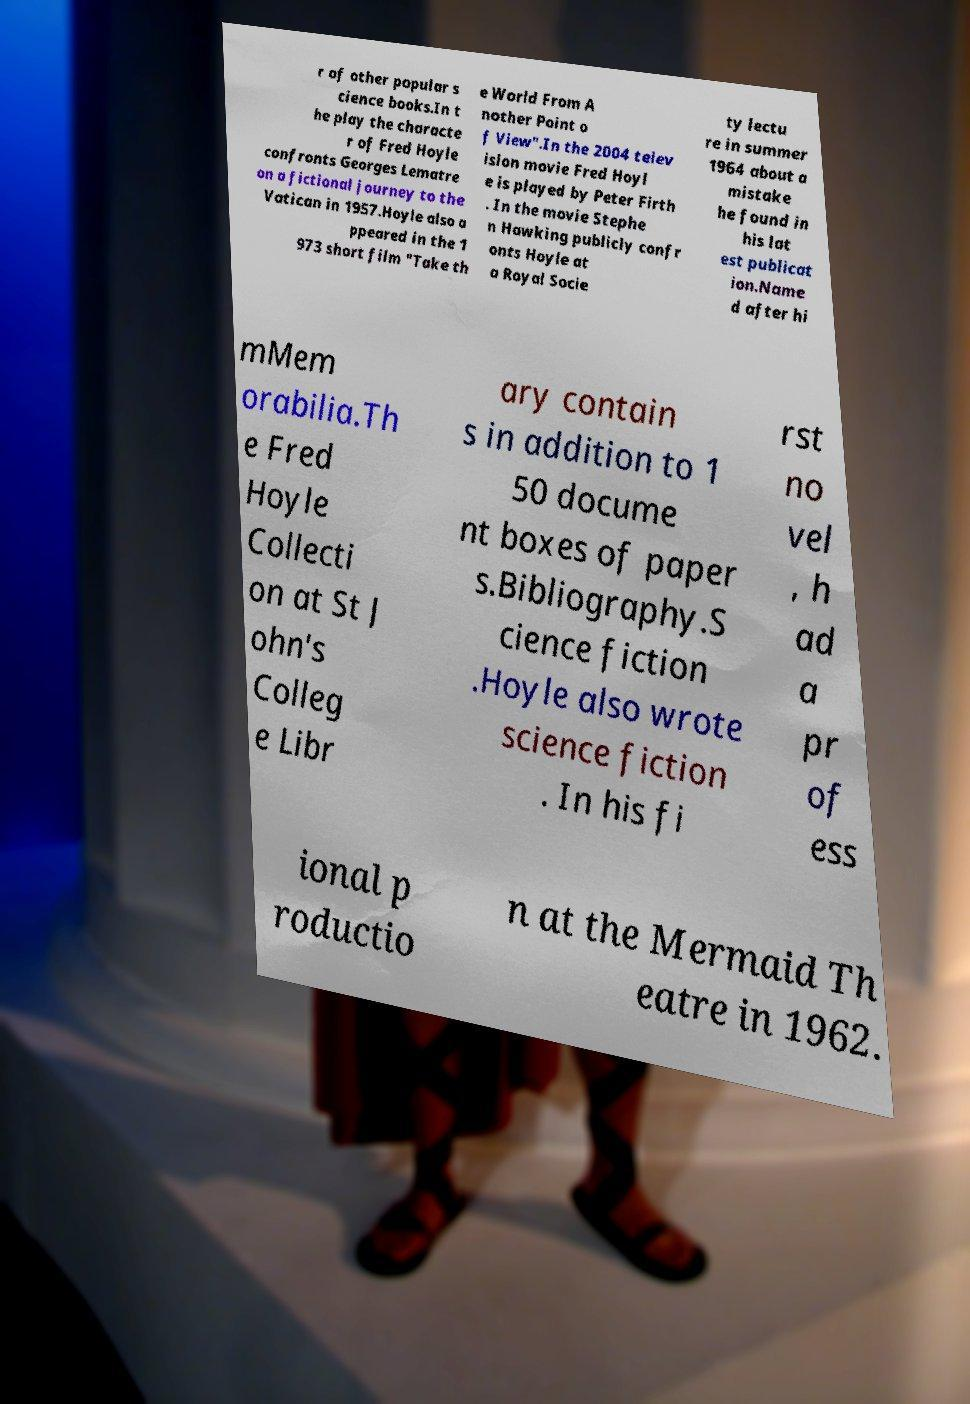What messages or text are displayed in this image? I need them in a readable, typed format. r of other popular s cience books.In t he play the characte r of Fred Hoyle confronts Georges Lematre on a fictional journey to the Vatican in 1957.Hoyle also a ppeared in the 1 973 short film "Take th e World From A nother Point o f View".In the 2004 telev ision movie Fred Hoyl e is played by Peter Firth . In the movie Stephe n Hawking publicly confr onts Hoyle at a Royal Socie ty lectu re in summer 1964 about a mistake he found in his lat est publicat ion.Name d after hi mMem orabilia.Th e Fred Hoyle Collecti on at St J ohn's Colleg e Libr ary contain s in addition to 1 50 docume nt boxes of paper s.Bibliography.S cience fiction .Hoyle also wrote science fiction . In his fi rst no vel , h ad a pr of ess ional p roductio n at the Mermaid Th eatre in 1962. 